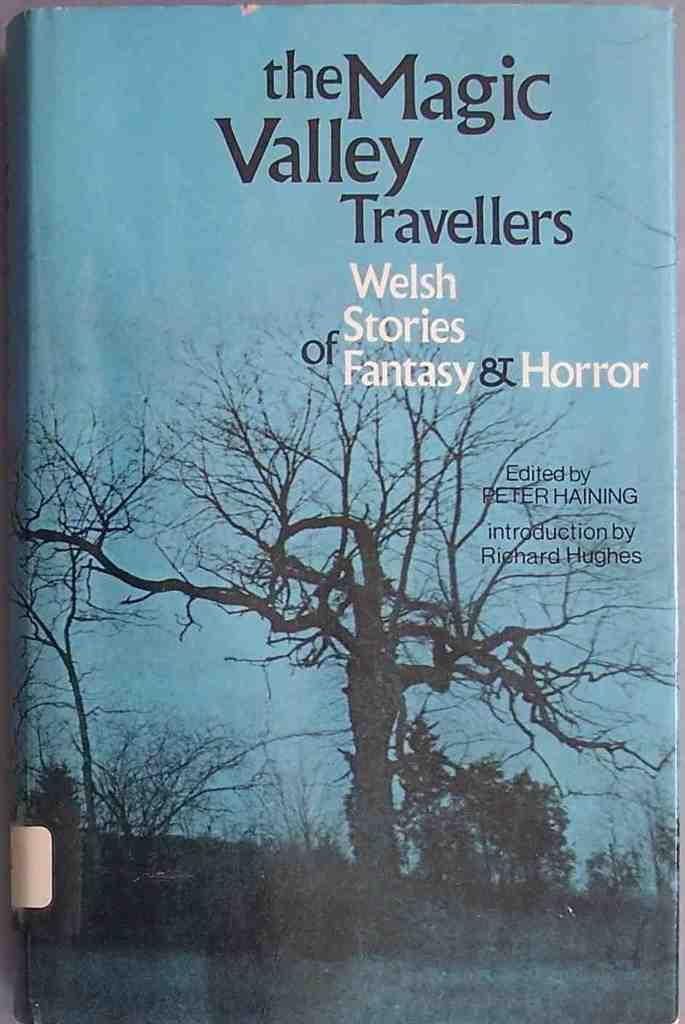<image>
Write a terse but informative summary of the picture. The Magic Valley Traveller was edited by Peter Haining. 